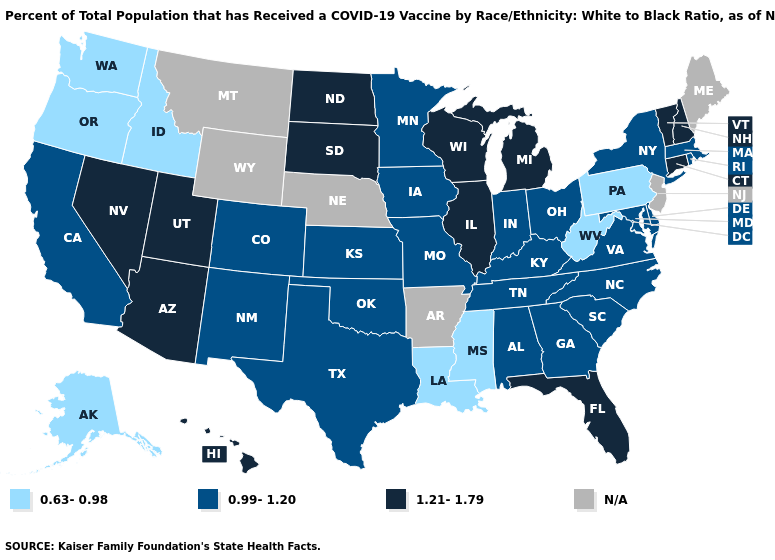How many symbols are there in the legend?
Be succinct. 4. Name the states that have a value in the range 0.99-1.20?
Be succinct. Alabama, California, Colorado, Delaware, Georgia, Indiana, Iowa, Kansas, Kentucky, Maryland, Massachusetts, Minnesota, Missouri, New Mexico, New York, North Carolina, Ohio, Oklahoma, Rhode Island, South Carolina, Tennessee, Texas, Virginia. Among the states that border New York , does Pennsylvania have the lowest value?
Be succinct. Yes. Does the map have missing data?
Write a very short answer. Yes. Among the states that border Nevada , does California have the highest value?
Give a very brief answer. No. Does Virginia have the lowest value in the USA?
Short answer required. No. Does North Dakota have the highest value in the MidWest?
Concise answer only. Yes. Does Colorado have the lowest value in the USA?
Answer briefly. No. Name the states that have a value in the range 0.99-1.20?
Short answer required. Alabama, California, Colorado, Delaware, Georgia, Indiana, Iowa, Kansas, Kentucky, Maryland, Massachusetts, Minnesota, Missouri, New Mexico, New York, North Carolina, Ohio, Oklahoma, Rhode Island, South Carolina, Tennessee, Texas, Virginia. Is the legend a continuous bar?
Write a very short answer. No. Which states hav the highest value in the South?
Keep it brief. Florida. Among the states that border Vermont , does New Hampshire have the lowest value?
Quick response, please. No. What is the value of Wyoming?
Concise answer only. N/A. Which states have the lowest value in the Northeast?
Give a very brief answer. Pennsylvania. 